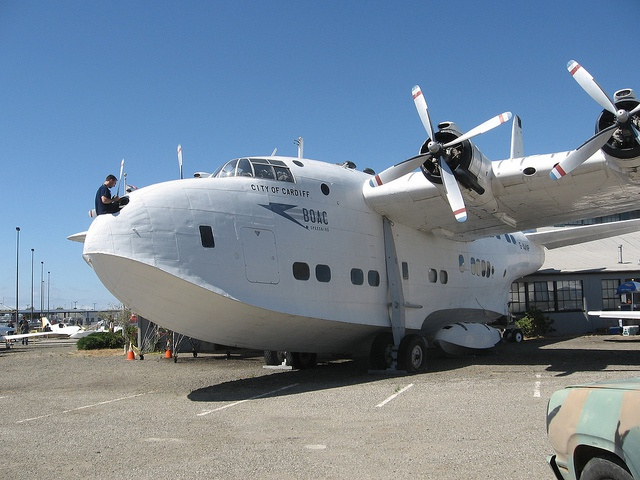Describe the objects in this image and their specific colors. I can see airplane in gray, darkgray, black, and lightgray tones, truck in gray, darkgray, tan, and lightgray tones, people in gray, black, and navy tones, airplane in gray, white, darkgray, and black tones, and airplane in gray, white, black, and darkgray tones in this image. 